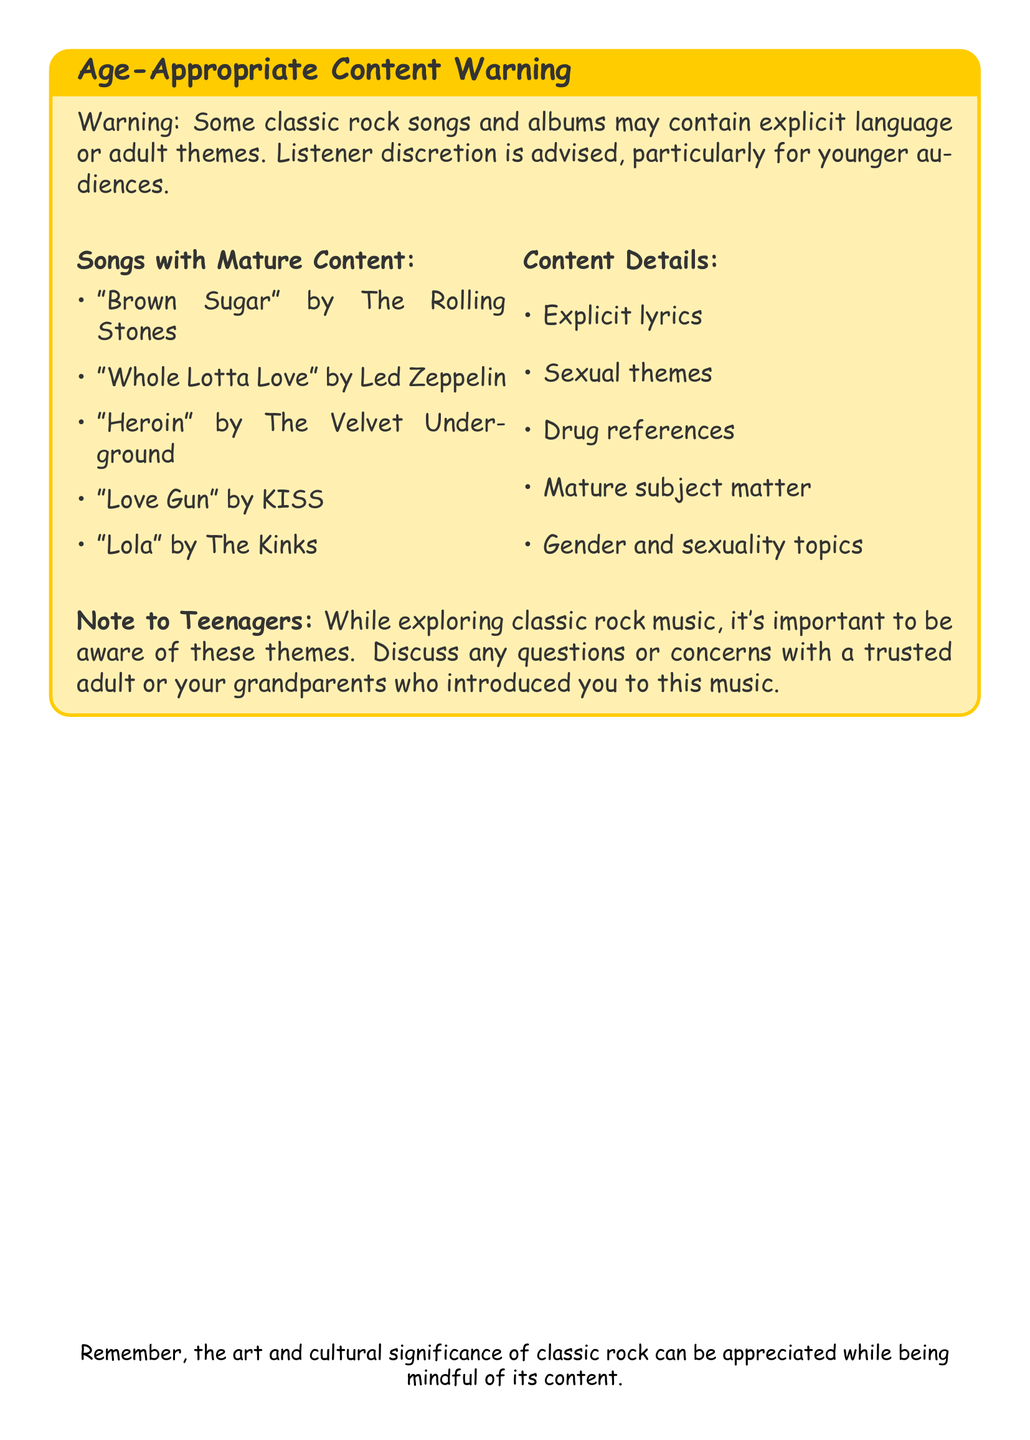What is the title of the warning? The title of the warning is prominently displayed at the top of the document, indicating it is about Age-Appropriate Content.
Answer: Age-Appropriate Content Warning How many songs are listed with mature content? The document provides a list of songs that contain mature content, specifically six titles are mentioned.
Answer: 5 Which classic rock band is associated with the song "Whole Lotta Love"? The song "Whole Lotta Love" is a famous track by a well-known classic rock band, identified in the document.
Answer: Led Zeppelin What type of themes are cautioned against for younger audiences? The document explicitly mentions a variety of themes that may be unsuitable for younger listeners, which it outlines in the Content Details section.
Answer: Explicit lyrics Who should teenagers discuss their questions or concerns with? The document advises teenagers to seek guidance regarding the content from a trusted individual while exploring classic rock music.
Answer: Trusted adult or grandparents What color is used for the warning background? The document specifies a color for the background of the warning box, enhancing visibility and emphasis on the content.
Answer: Yellow 